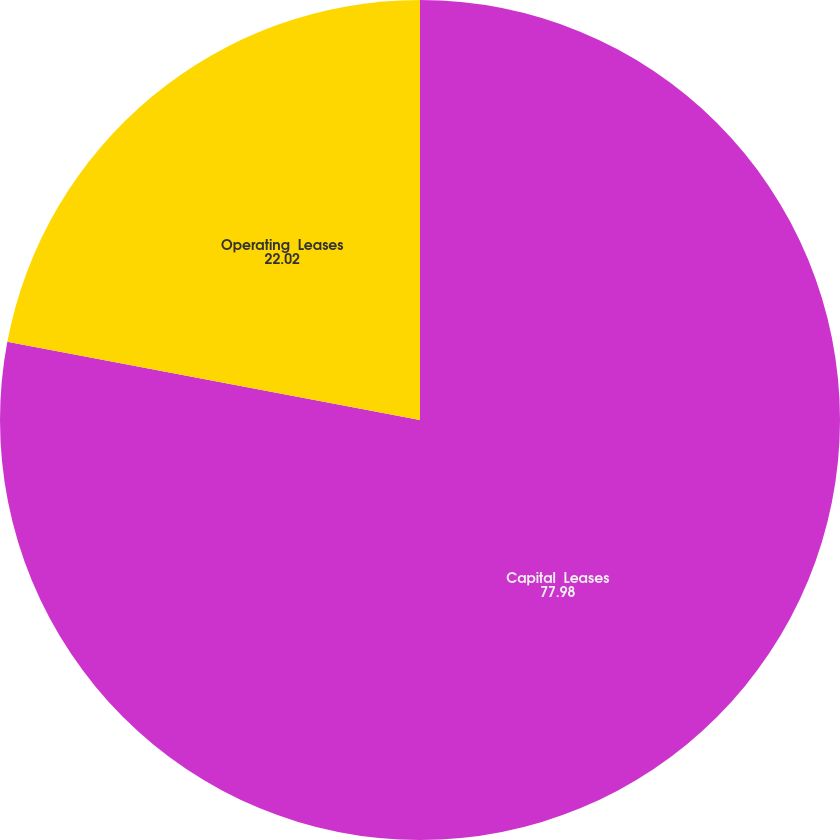Convert chart to OTSL. <chart><loc_0><loc_0><loc_500><loc_500><pie_chart><fcel>Capital  Leases<fcel>Operating  Leases<nl><fcel>77.98%<fcel>22.02%<nl></chart> 